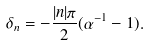Convert formula to latex. <formula><loc_0><loc_0><loc_500><loc_500>\delta _ { n } = - \frac { | n | \pi } { 2 } ( \alpha ^ { - 1 } - 1 ) .</formula> 